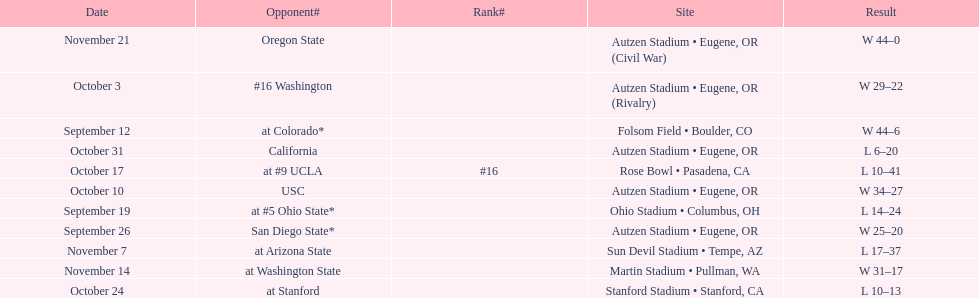Did the team win or lose more games? Win. 